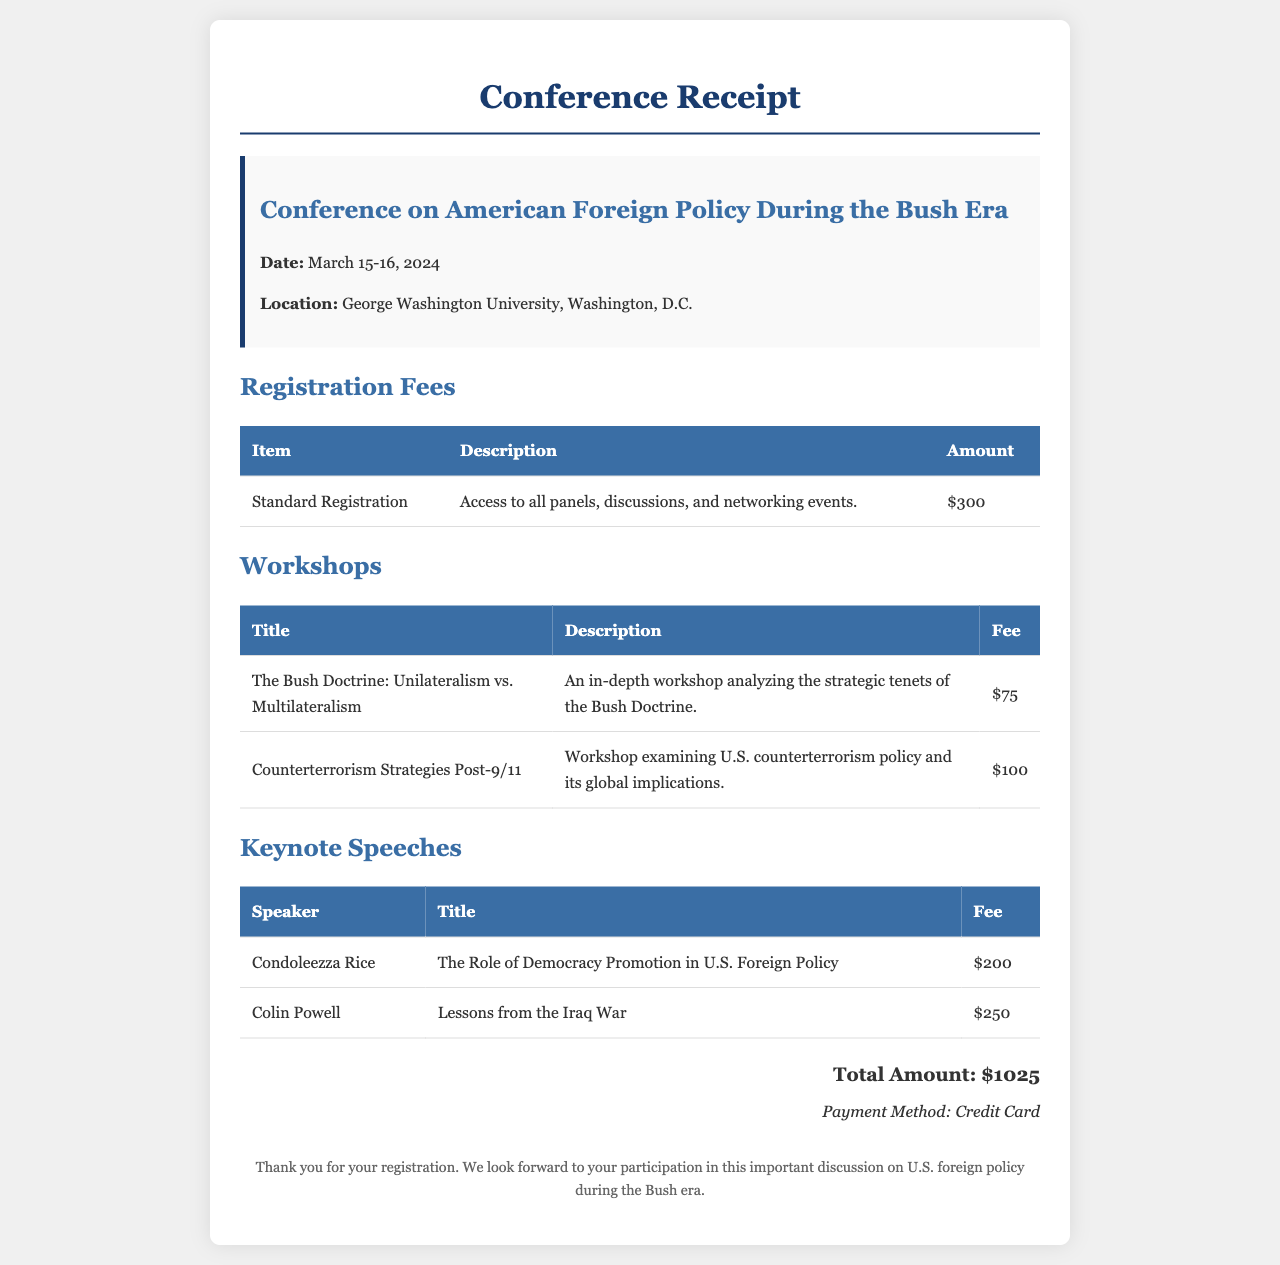What is the date of the conference? The date of the conference is specified in the document, which states it takes place on March 15-16, 2024.
Answer: March 15-16, 2024 What is the total amount due for the conference? The total amount is listed at the bottom of the receipt, summarizing the fees for registration, workshops, and keynote speeches.
Answer: $1025 Who is one of the keynote speakers? The document provides a list of keynote speakers, one of whom is mentioned as Condoleezza Rice.
Answer: Condoleezza Rice How much does the workshop on counterterrorism strategies cost? The fee for that specific workshop is included in the workshop section of the document.
Answer: $100 What institution is hosting the conference? The host location is stated clearly in the conference information section of the receipt.
Answer: George Washington University How many workshops are listed in the document? The document presents two workshops under the workshops section.
Answer: 2 What payment method was used for the registration? The payment method is indicated at the end of the receipt.
Answer: Credit Card What topic does Colin Powell's keynote speech address? The title of Colin Powell's keynote speech is included in the keynote speeches section of the document.
Answer: Lessons from the Iraq War What does the standard registration fee provide access to? The description associated with the standard registration fee outlines access to various conference events.
Answer: All panels, discussions, and networking events 